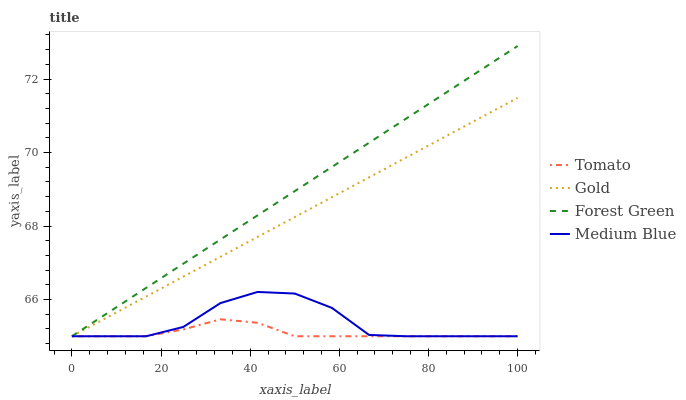Does Tomato have the minimum area under the curve?
Answer yes or no. Yes. Does Forest Green have the maximum area under the curve?
Answer yes or no. Yes. Does Medium Blue have the minimum area under the curve?
Answer yes or no. No. Does Medium Blue have the maximum area under the curve?
Answer yes or no. No. Is Forest Green the smoothest?
Answer yes or no. Yes. Is Medium Blue the roughest?
Answer yes or no. Yes. Is Medium Blue the smoothest?
Answer yes or no. No. Is Forest Green the roughest?
Answer yes or no. No. Does Medium Blue have the highest value?
Answer yes or no. No. 